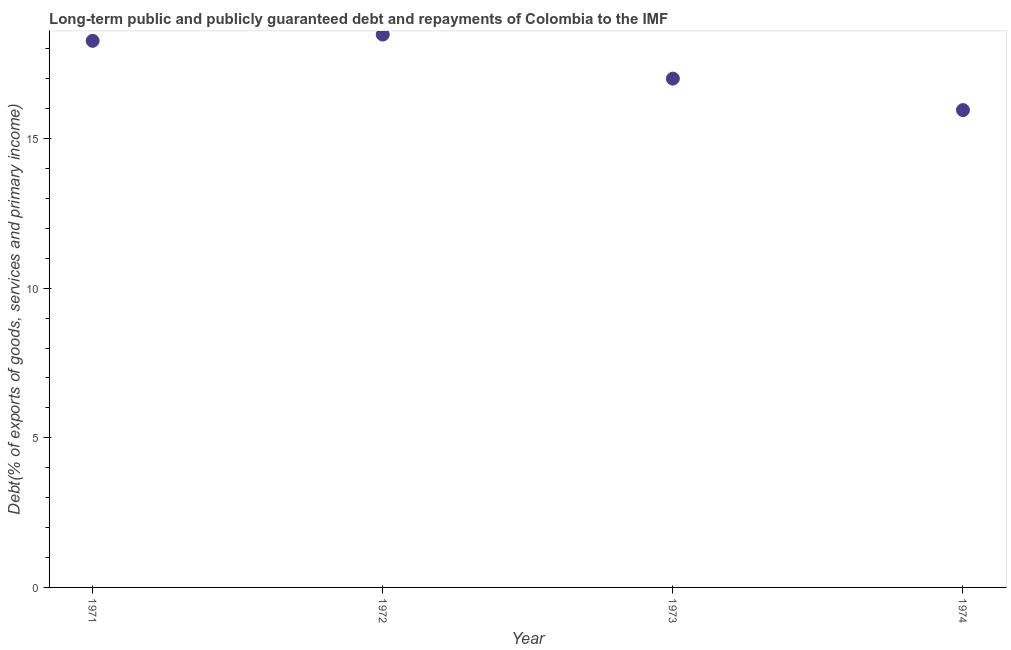What is the debt service in 1973?
Your answer should be very brief. 17. Across all years, what is the maximum debt service?
Your answer should be very brief. 18.47. Across all years, what is the minimum debt service?
Offer a terse response. 15.95. In which year was the debt service maximum?
Give a very brief answer. 1972. In which year was the debt service minimum?
Give a very brief answer. 1974. What is the sum of the debt service?
Offer a terse response. 69.69. What is the difference between the debt service in 1972 and 1974?
Ensure brevity in your answer.  2.52. What is the average debt service per year?
Your answer should be compact. 17.42. What is the median debt service?
Your response must be concise. 17.63. In how many years, is the debt service greater than 16 %?
Make the answer very short. 3. Do a majority of the years between 1973 and 1974 (inclusive) have debt service greater than 12 %?
Your answer should be compact. Yes. What is the ratio of the debt service in 1972 to that in 1973?
Ensure brevity in your answer.  1.09. Is the debt service in 1972 less than that in 1974?
Give a very brief answer. No. Is the difference between the debt service in 1971 and 1973 greater than the difference between any two years?
Ensure brevity in your answer.  No. What is the difference between the highest and the second highest debt service?
Ensure brevity in your answer.  0.21. What is the difference between the highest and the lowest debt service?
Make the answer very short. 2.52. In how many years, is the debt service greater than the average debt service taken over all years?
Give a very brief answer. 2. Does the debt service monotonically increase over the years?
Your answer should be very brief. No. What is the difference between two consecutive major ticks on the Y-axis?
Give a very brief answer. 5. What is the title of the graph?
Ensure brevity in your answer.  Long-term public and publicly guaranteed debt and repayments of Colombia to the IMF. What is the label or title of the X-axis?
Your answer should be very brief. Year. What is the label or title of the Y-axis?
Offer a very short reply. Debt(% of exports of goods, services and primary income). What is the Debt(% of exports of goods, services and primary income) in 1971?
Offer a very short reply. 18.26. What is the Debt(% of exports of goods, services and primary income) in 1972?
Keep it short and to the point. 18.47. What is the Debt(% of exports of goods, services and primary income) in 1973?
Keep it short and to the point. 17. What is the Debt(% of exports of goods, services and primary income) in 1974?
Your answer should be very brief. 15.95. What is the difference between the Debt(% of exports of goods, services and primary income) in 1971 and 1972?
Ensure brevity in your answer.  -0.21. What is the difference between the Debt(% of exports of goods, services and primary income) in 1971 and 1973?
Provide a succinct answer. 1.26. What is the difference between the Debt(% of exports of goods, services and primary income) in 1971 and 1974?
Your answer should be compact. 2.31. What is the difference between the Debt(% of exports of goods, services and primary income) in 1972 and 1973?
Ensure brevity in your answer.  1.47. What is the difference between the Debt(% of exports of goods, services and primary income) in 1972 and 1974?
Make the answer very short. 2.52. What is the difference between the Debt(% of exports of goods, services and primary income) in 1973 and 1974?
Ensure brevity in your answer.  1.05. What is the ratio of the Debt(% of exports of goods, services and primary income) in 1971 to that in 1972?
Offer a terse response. 0.99. What is the ratio of the Debt(% of exports of goods, services and primary income) in 1971 to that in 1973?
Make the answer very short. 1.07. What is the ratio of the Debt(% of exports of goods, services and primary income) in 1971 to that in 1974?
Give a very brief answer. 1.15. What is the ratio of the Debt(% of exports of goods, services and primary income) in 1972 to that in 1973?
Provide a succinct answer. 1.09. What is the ratio of the Debt(% of exports of goods, services and primary income) in 1972 to that in 1974?
Offer a terse response. 1.16. What is the ratio of the Debt(% of exports of goods, services and primary income) in 1973 to that in 1974?
Give a very brief answer. 1.07. 